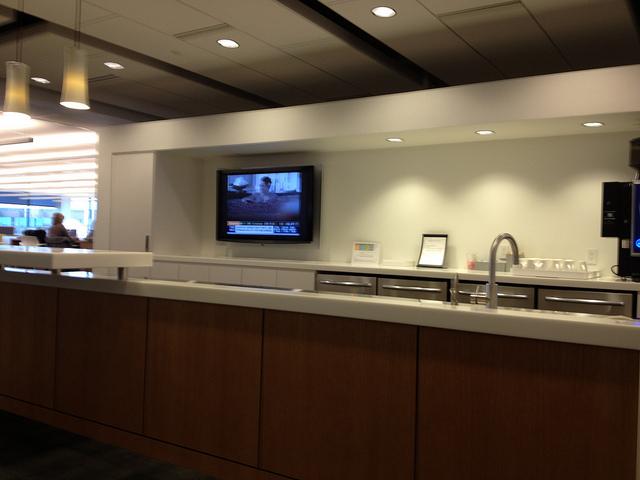Is the tv on?
Answer briefly. Yes. What room is this?
Keep it brief. Kitchen. How many TVs is in the picture?
Concise answer only. 1. 